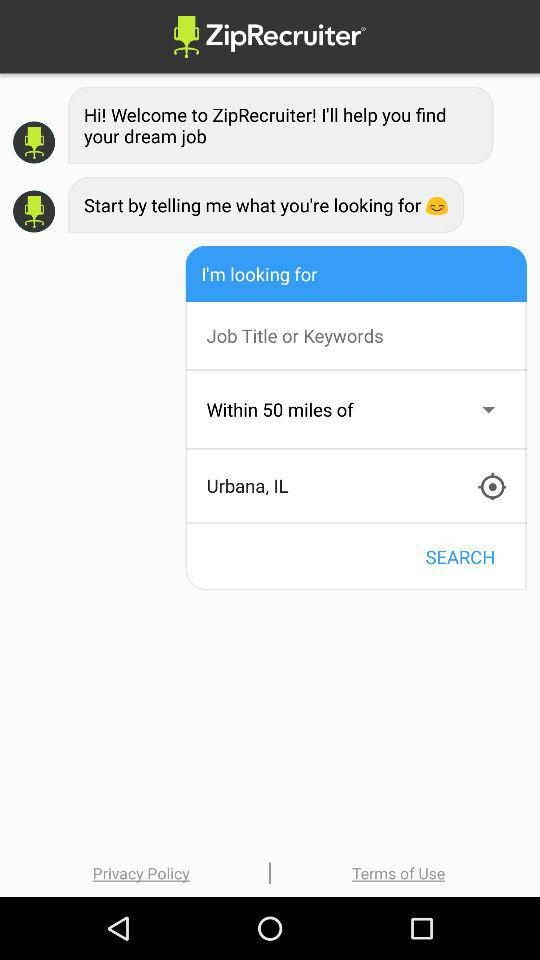What is the application name? The application name is "ZipRecruiter". 